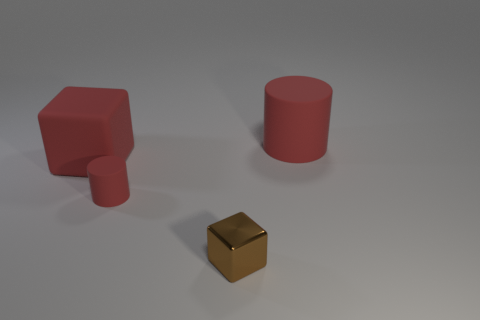What can the surface the objects are resting on tell us about the context of the image? The objects rest on a smooth, neutral-gray surface that appears to be seamless and extends to the background without any clear horizon line. This typically suggests a studio setting designed for the purpose of product visualization or graphical rendering without distractions, which is a common technique to ensure that the focus remains solely on the objects themselves. 